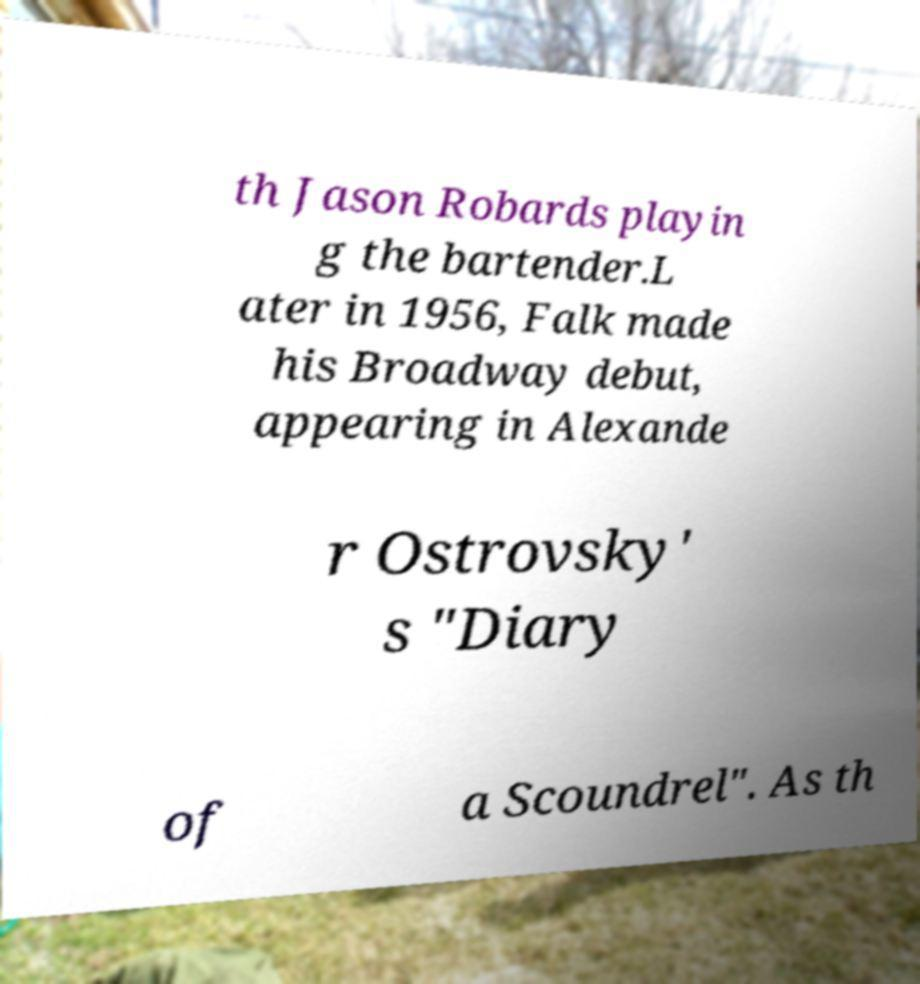Please read and relay the text visible in this image. What does it say? th Jason Robards playin g the bartender.L ater in 1956, Falk made his Broadway debut, appearing in Alexande r Ostrovsky' s "Diary of a Scoundrel". As th 